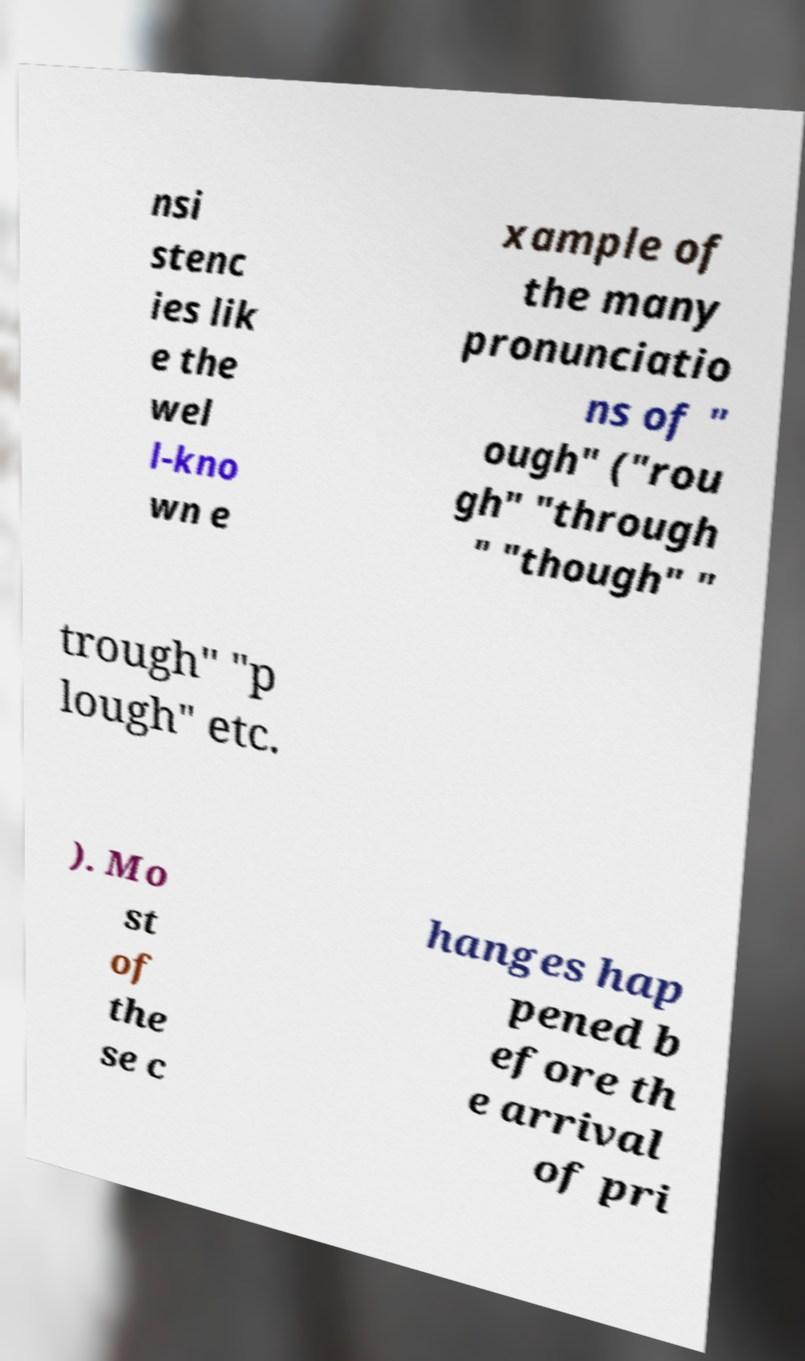Can you read and provide the text displayed in the image?This photo seems to have some interesting text. Can you extract and type it out for me? nsi stenc ies lik e the wel l-kno wn e xample of the many pronunciatio ns of " ough" ("rou gh" "through " "though" " trough" "p lough" etc. ). Mo st of the se c hanges hap pened b efore th e arrival of pri 